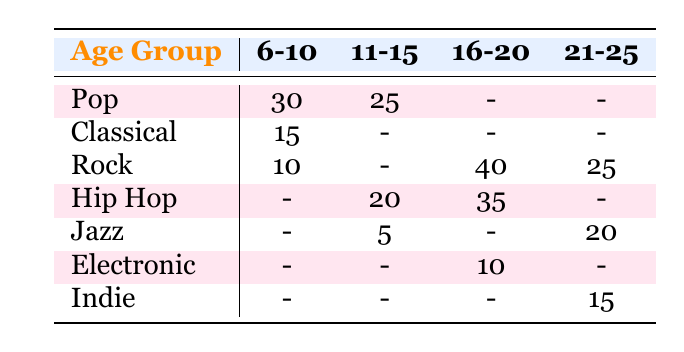What is the count of students aged 6-10 who prefer Pop music? From the table, under the age group "6-10," the count for Pop music is directly listed as 30.
Answer: 30 What are the preferred genres for students aged 21-25? In the 21-25 age group, the genres listed are Jazz (20), Indie (15), and Rock (25).
Answer: Jazz, Indie, Rock Did any students aged 11-15 prefer Classical music? Looking at the 11-15 age group, there is a dash in the Classical row indicating no students preferred this genre in this age group.
Answer: No Which age group has the highest preference for Rock music? The table shows that the 16-20 age group has the highest count for Rock music at 40, as opposed to the counts of 10 and 25 in the younger and older age groups respectively.
Answer: 16-20 For the age group 11-15, what is the total number of students who prefer Hip Hop and Jazz combined? For the 11-15 age group, the count for Hip Hop is 20 and for Jazz is 5. Adding these, 20 + 5 equals 25 students prefer these genres.
Answer: 25 What is the difference in the number of students who prefer Pop music between the age groups 6-10 and 11-15? The count for Pop in the 6-10 age group is 30, and in the 11-15 age group, it is 25. The difference is 30 - 25 which equals 5.
Answer: 5 Is it true that the 16-20 age group has a higher preference for Electronic music than the 21-25 age group does for Indie music? The 16-20 age group has a count of 10 for Electronic music, while the 21-25 age group shows a count of 15 for Indie music, making the statement false.
Answer: No Which age group has the least interest in Jazz? The 6-10 and 11-15 age groups both have a count of 0 for Jazz, but 11-15 has at least one genre (Hip Hop), so it indicates less interest overall.
Answer: 6-10 What are the total counts of all genres preferred by students aged 21-25? The counts for the genres preferred by students aged 21-25 are Jazz (20), Indie (15), and Rock (25). Summing these, we get 20 + 15 + 25 = 60.
Answer: 60 